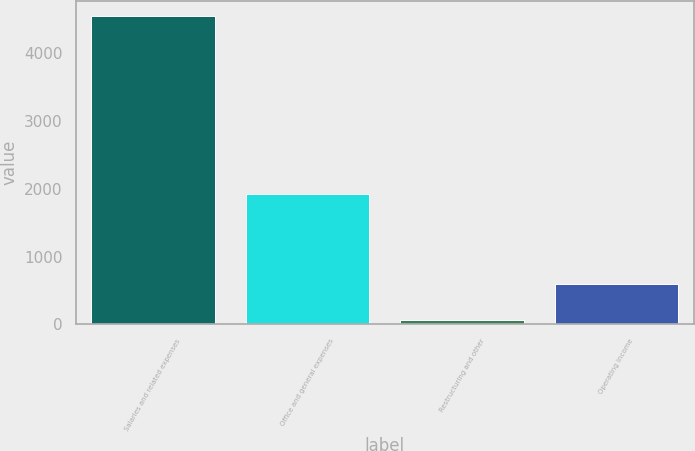Convert chart. <chart><loc_0><loc_0><loc_500><loc_500><bar_chart><fcel>Salaries and related expenses<fcel>Office and general expenses<fcel>Restructuring and other<fcel>Operating income<nl><fcel>4545.5<fcel>1917.9<fcel>60.6<fcel>598.3<nl></chart> 